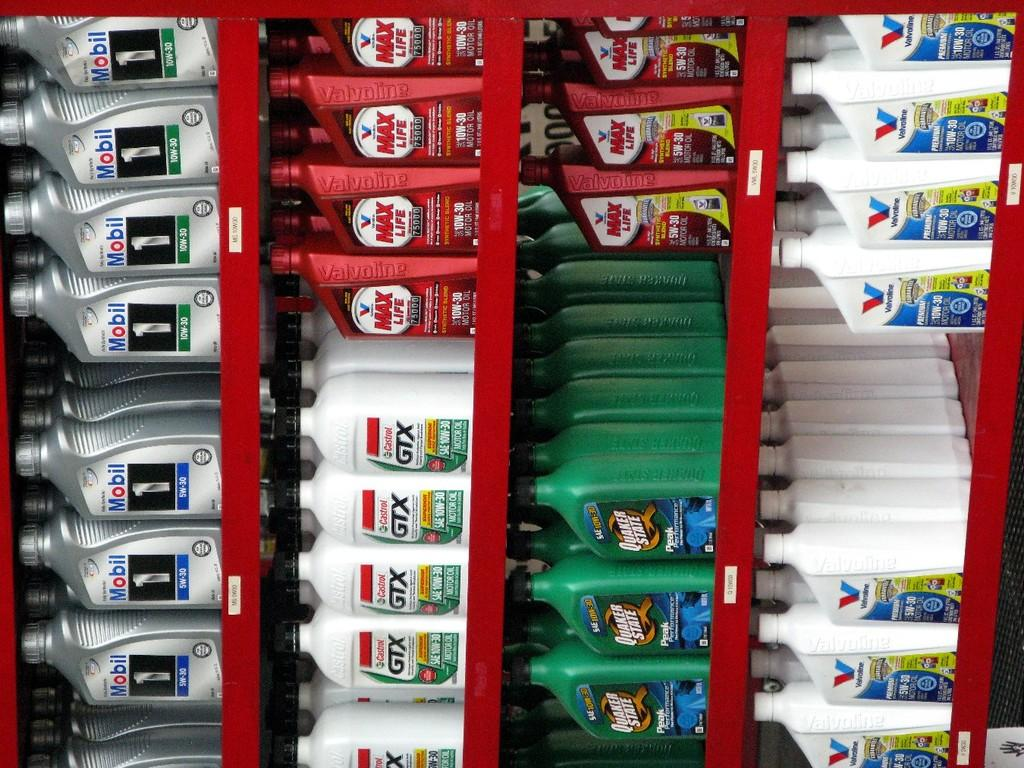<image>
Give a short and clear explanation of the subsequent image. Line of products for car engine oil including GTX and Mobil. 